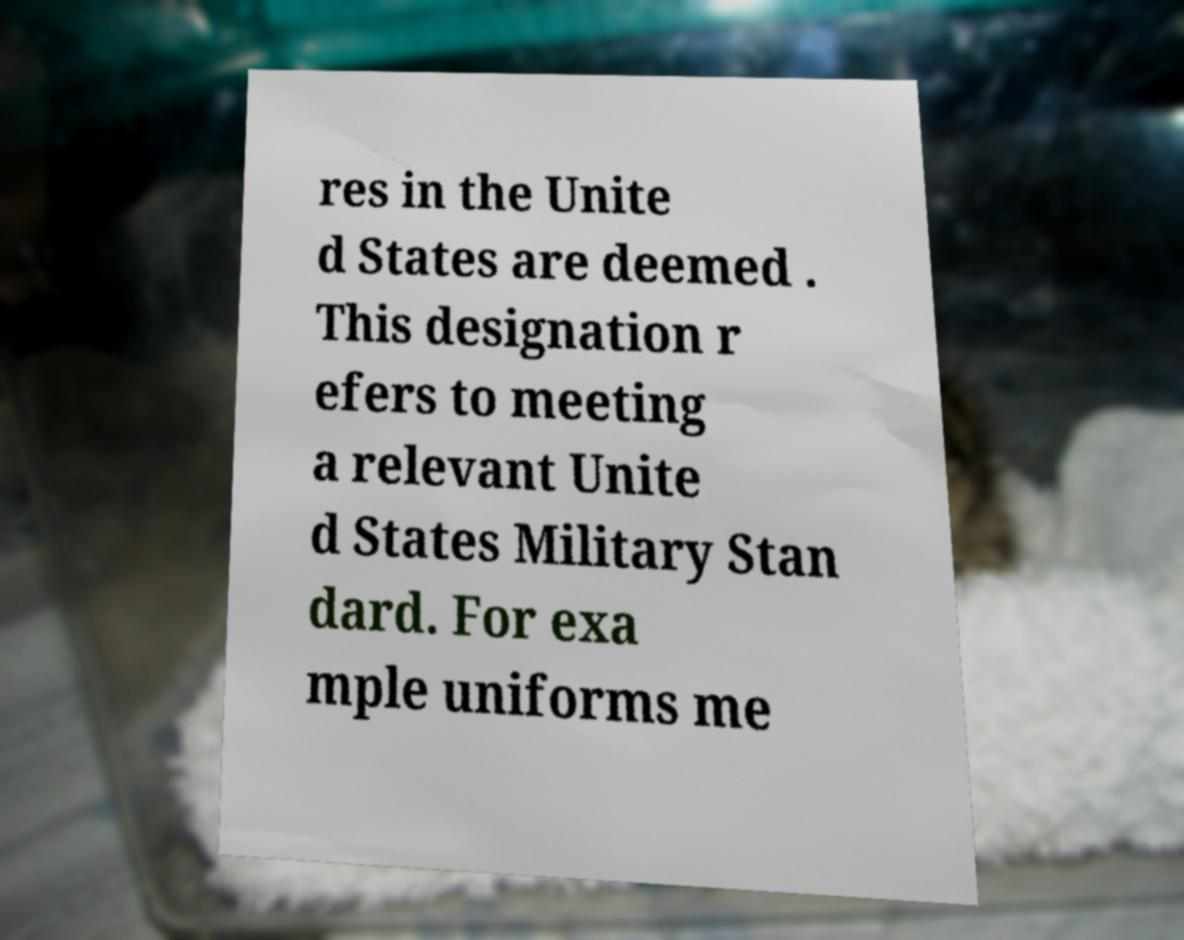Can you accurately transcribe the text from the provided image for me? res in the Unite d States are deemed . This designation r efers to meeting a relevant Unite d States Military Stan dard. For exa mple uniforms me 